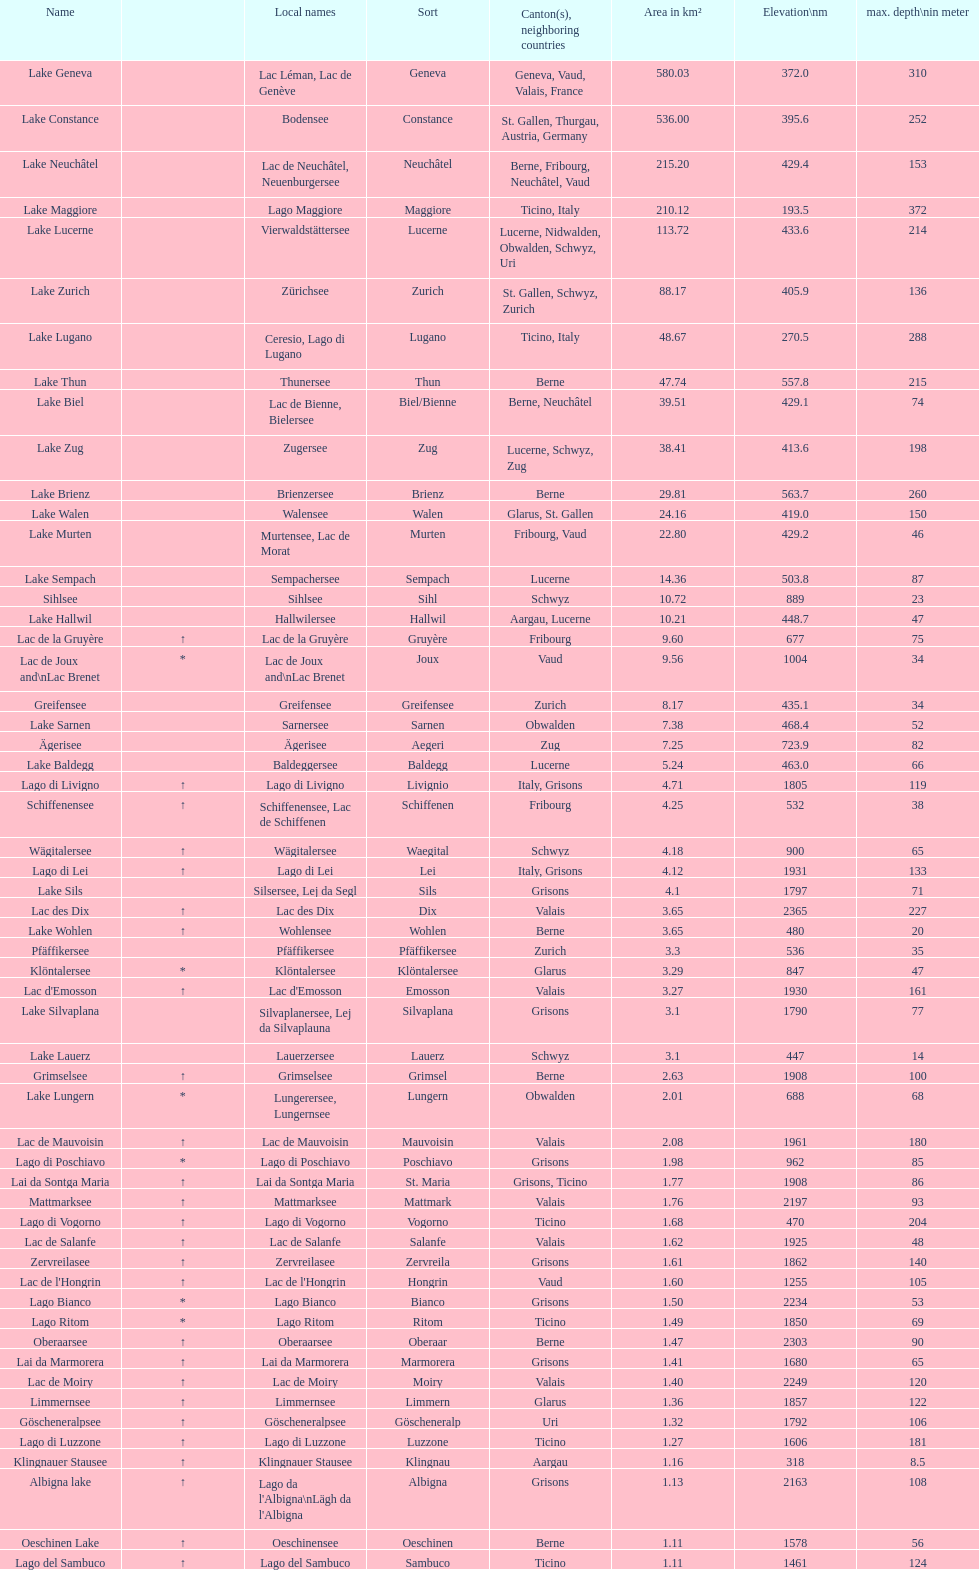Which lake has the largest elevation? Lac des Dix. 